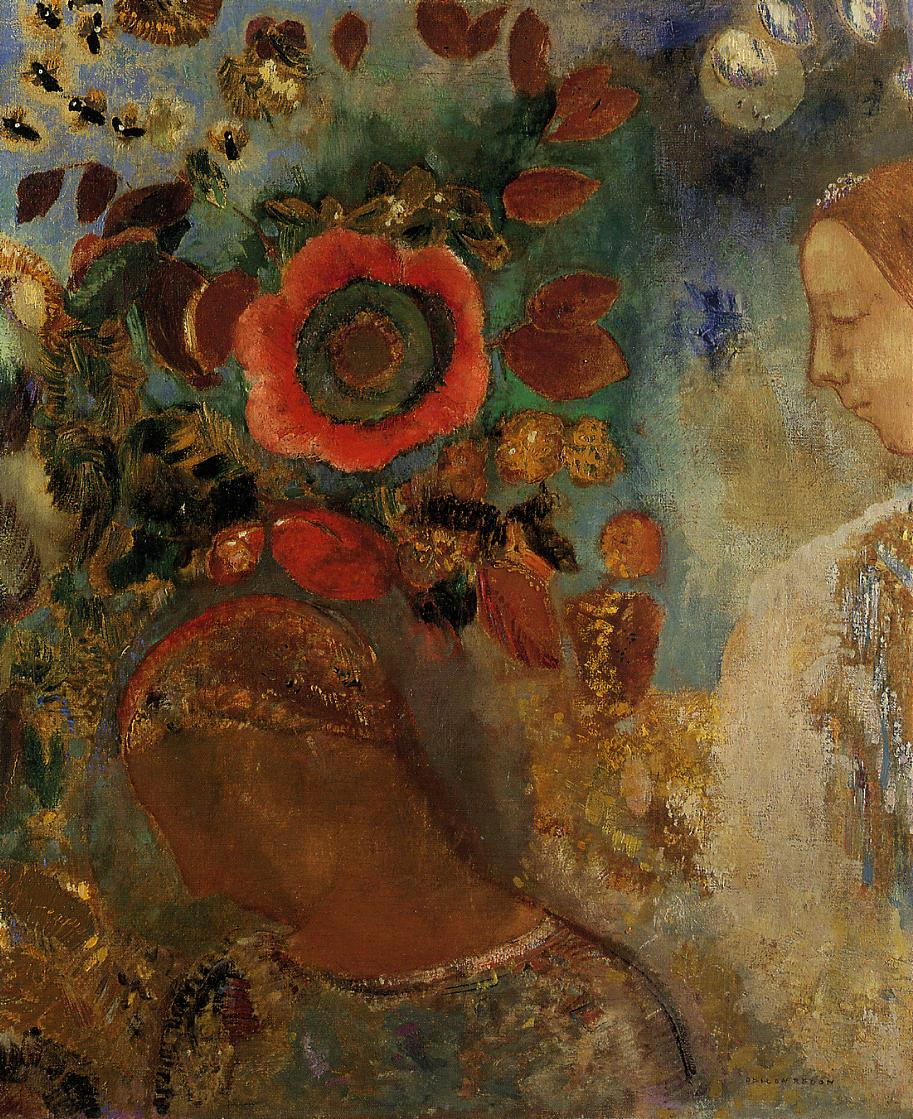If you could step into this image, what sounds and scents might you experience? Stepping into the painting, you might be enveloped by the subtle sounds of rustling leaves and the gentle hum of distant bees hovering near the vibrant flowers. The air would carry a mix of floral fragrances, dominated by the sweet, intoxicating scent of the large red bloom that stands prominently at the center. Faint chirps of hidden birds might echo through the background, adding to the serene and immersive ambiance. Each breath would be filled with the freshness of nature, while the soft whisper of the wind moves through the layered flora, creating a harmonious symphony of natural sounds and scents. How would the scene change if it were transitioning from day to night? As the scene transitions from day to night, the vibrant hues of the flowers would gradually deepen and take on richer, more subdued tones under the dimming light. The sky would shift from a warm, golden glow to a cooler, dusk-like ambiance. Stars might begin to twinkle faintly, casting a soft luminescence over the garden. The large red flower would still stand out, glowing subtly in the moonlight, its petals now shaded with a deeper, more mysterious tone. The soundscape would transform, with daytime buzz fading into the gentle chirping of crickets and the occasional hoot of a distant owl. The fragrance of the flowers might intensify in the cooler air, adding a touch of nocturnal allure to the scene. This transformation would evoke a sense of peaceful transition, deepening the contemplative mood and highlighting the timeless ebb and flow of nature. 